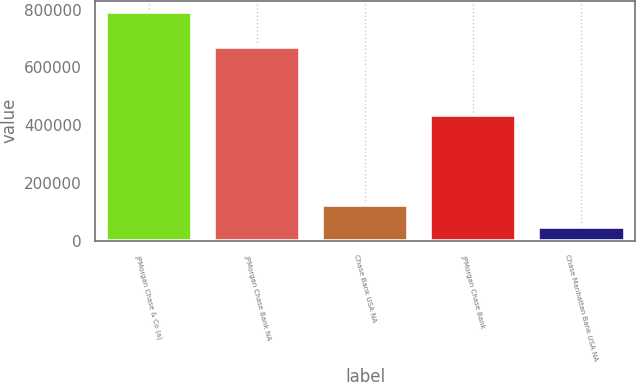<chart> <loc_0><loc_0><loc_500><loc_500><bar_chart><fcel>JPMorgan Chase & Co (a)<fcel>JPMorgan Chase Bank NA<fcel>Chase Bank USA NA<fcel>JPMorgan Chase Bank<fcel>Chase Manhattan Bank USA NA<nl><fcel>791373<fcel>670295<fcel>122364<fcel>434218<fcel>48030<nl></chart> 